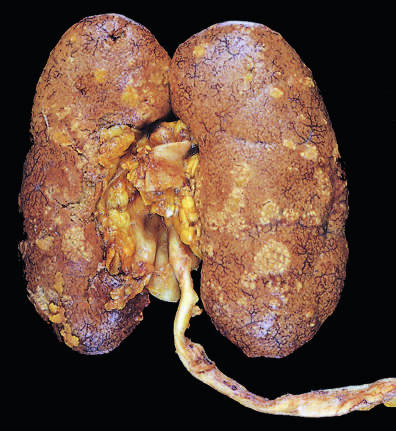s the lower pole relatively unaffected?
Answer the question using a single word or phrase. Yes 